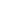Convert formula to latex. <formula><loc_0><loc_0><loc_500><loc_500>\begin{matrix} \\ \\ \\ \\ \end{matrix}</formula> 